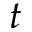Convert formula to latex. <formula><loc_0><loc_0><loc_500><loc_500>t</formula> 